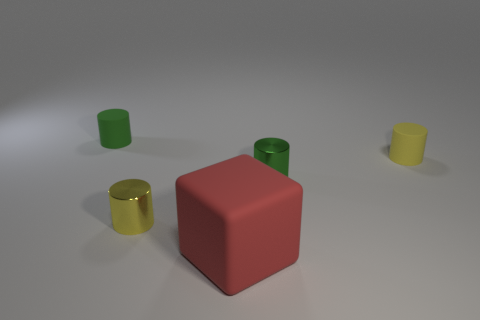Subtract all small green rubber cylinders. How many cylinders are left? 3 Subtract all yellow cylinders. How many cylinders are left? 2 Add 4 green rubber cylinders. How many objects exist? 9 Subtract all cyan blocks. How many purple cylinders are left? 0 Subtract all blocks. How many objects are left? 4 Subtract all big matte objects. Subtract all cubes. How many objects are left? 3 Add 5 yellow rubber objects. How many yellow rubber objects are left? 6 Add 4 tiny blue objects. How many tiny blue objects exist? 4 Subtract 0 red spheres. How many objects are left? 5 Subtract all purple cylinders. Subtract all gray cubes. How many cylinders are left? 4 